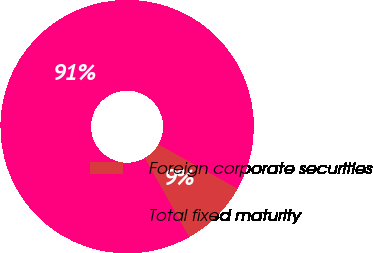Convert chart to OTSL. <chart><loc_0><loc_0><loc_500><loc_500><pie_chart><fcel>Foreign corporate securities<fcel>Total fixed maturity<nl><fcel>8.73%<fcel>91.27%<nl></chart> 